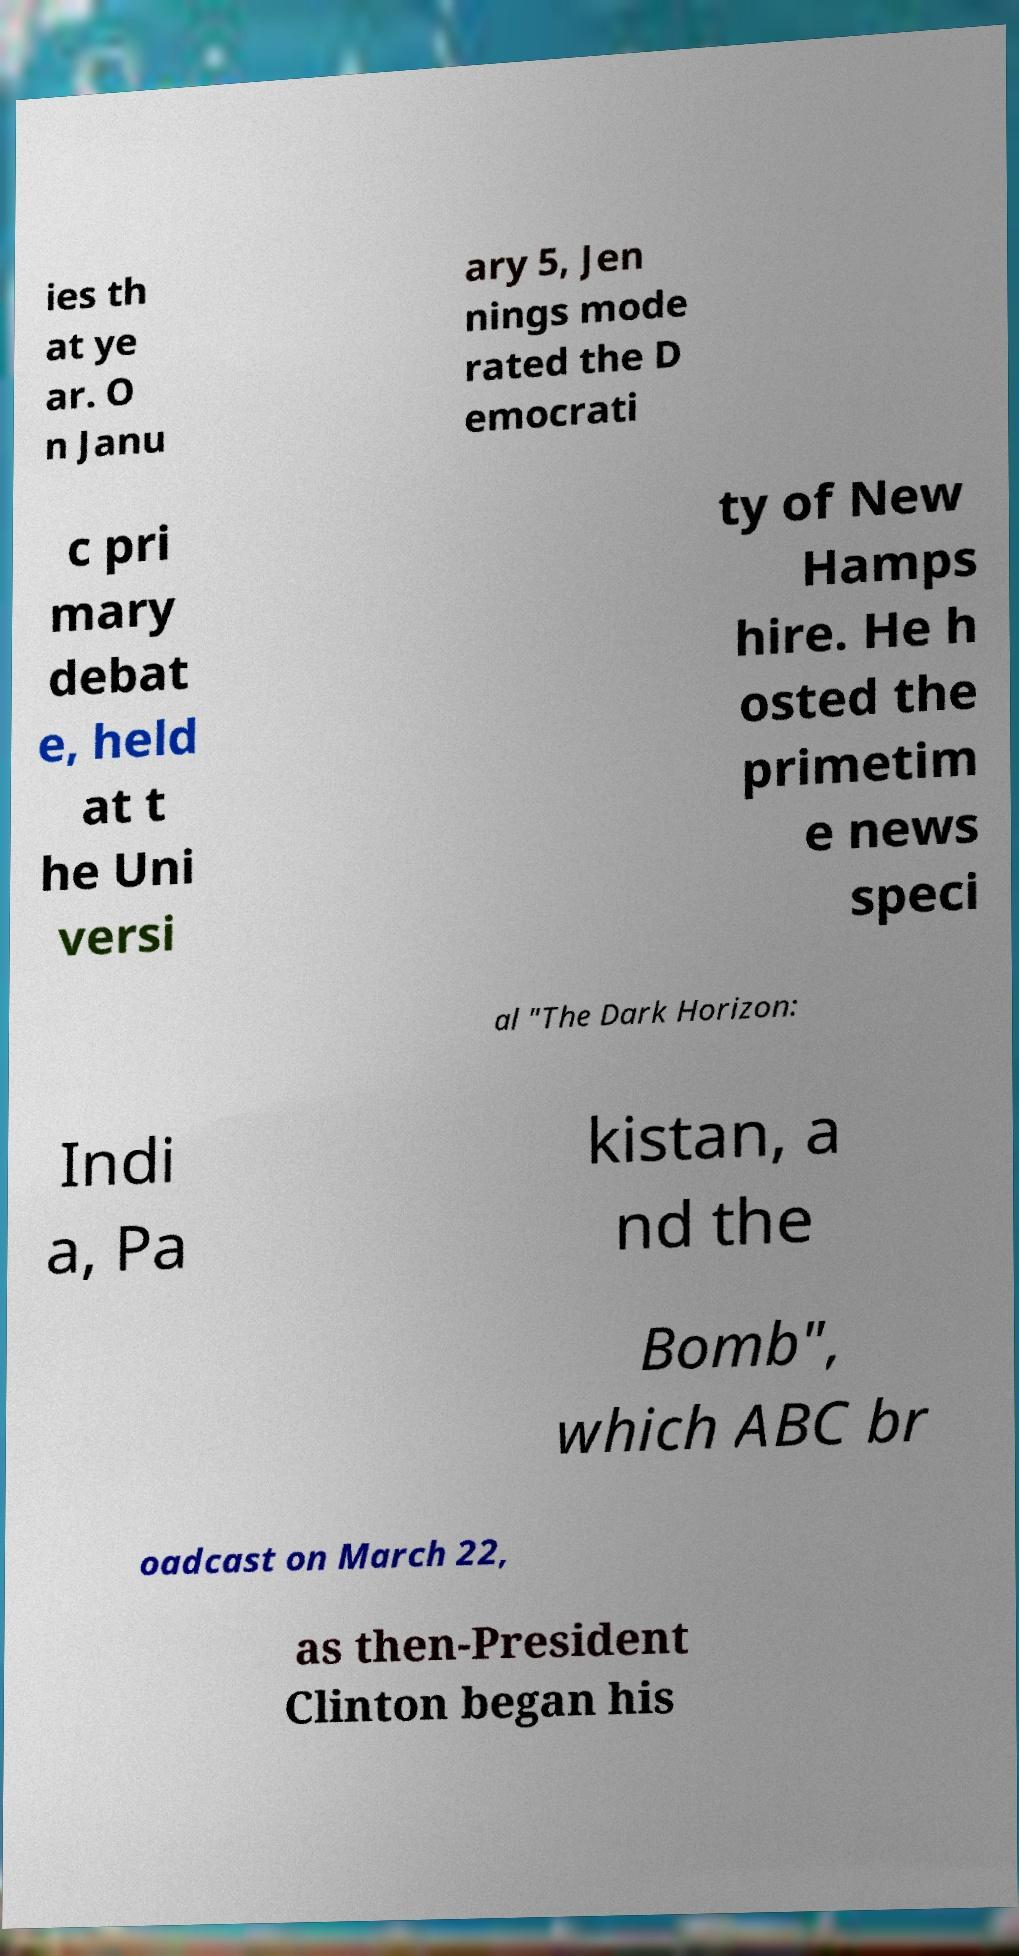Please read and relay the text visible in this image. What does it say? ies th at ye ar. O n Janu ary 5, Jen nings mode rated the D emocrati c pri mary debat e, held at t he Uni versi ty of New Hamps hire. He h osted the primetim e news speci al "The Dark Horizon: Indi a, Pa kistan, a nd the Bomb", which ABC br oadcast on March 22, as then-President Clinton began his 